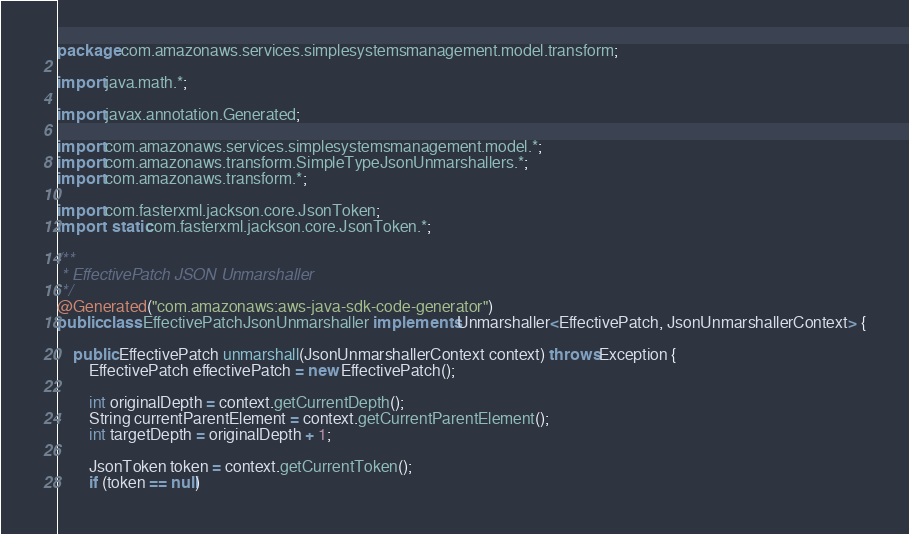Convert code to text. <code><loc_0><loc_0><loc_500><loc_500><_Java_>package com.amazonaws.services.simplesystemsmanagement.model.transform;

import java.math.*;

import javax.annotation.Generated;

import com.amazonaws.services.simplesystemsmanagement.model.*;
import com.amazonaws.transform.SimpleTypeJsonUnmarshallers.*;
import com.amazonaws.transform.*;

import com.fasterxml.jackson.core.JsonToken;
import static com.fasterxml.jackson.core.JsonToken.*;

/**
 * EffectivePatch JSON Unmarshaller
 */
@Generated("com.amazonaws:aws-java-sdk-code-generator")
public class EffectivePatchJsonUnmarshaller implements Unmarshaller<EffectivePatch, JsonUnmarshallerContext> {

    public EffectivePatch unmarshall(JsonUnmarshallerContext context) throws Exception {
        EffectivePatch effectivePatch = new EffectivePatch();

        int originalDepth = context.getCurrentDepth();
        String currentParentElement = context.getCurrentParentElement();
        int targetDepth = originalDepth + 1;

        JsonToken token = context.getCurrentToken();
        if (token == null)</code> 